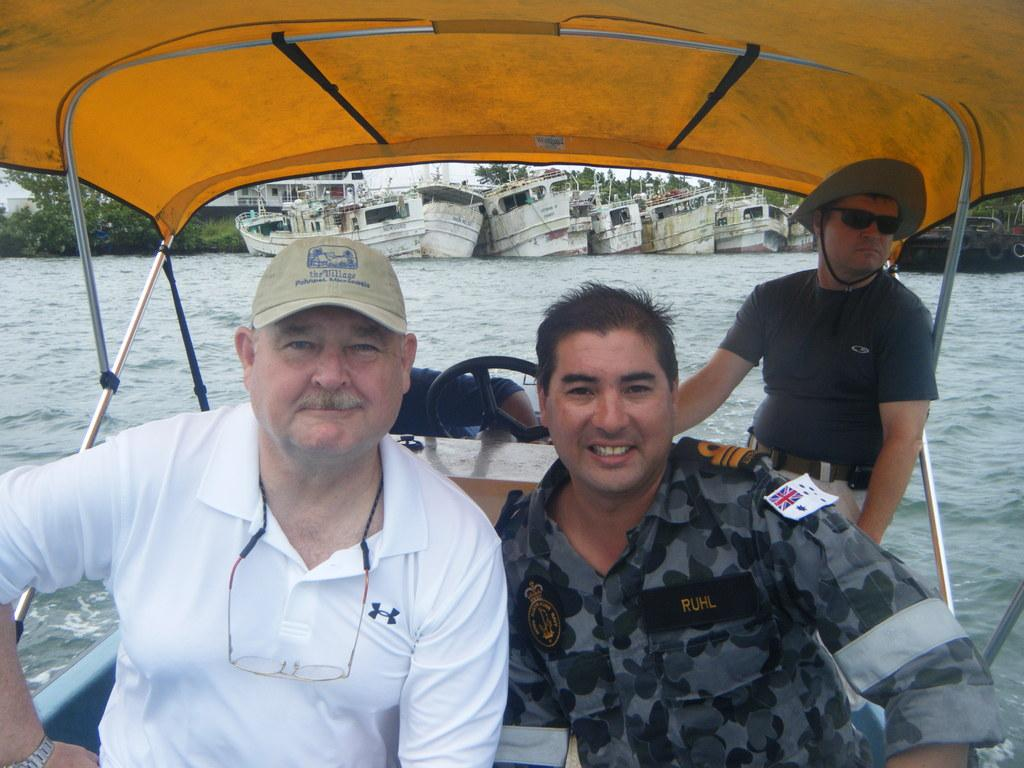What are the people in the image doing? The persons in the image are sitting on a boat. Where is the boat located in the image? The boat is in the center of the image. What can be seen in the background of the image? Water is present in the background of the image. What type of vegetation is visible at the top of the image? Plants are visible at the top of the image. How many passengers are on the boat, and what are they wearing? There is no information about the number of passengers or their clothing in the image. What type of kick can be seen in the image? There is no kick present in the image. 